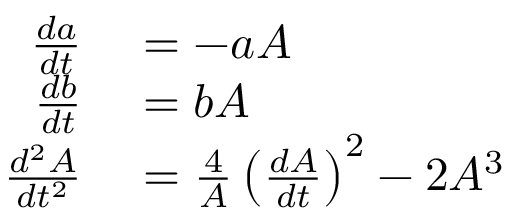Convert formula to latex. <formula><loc_0><loc_0><loc_500><loc_500>\begin{array} { r l } { \frac { d a } { d t } } & = - a A } \\ { \frac { d b } { d t } } & = b A } \\ { \frac { d ^ { 2 } A } { d t ^ { 2 } } } & = \frac { 4 } { A } \left ( \frac { d A } { d t } \right ) ^ { 2 } - 2 A ^ { 3 } } \end{array}</formula> 